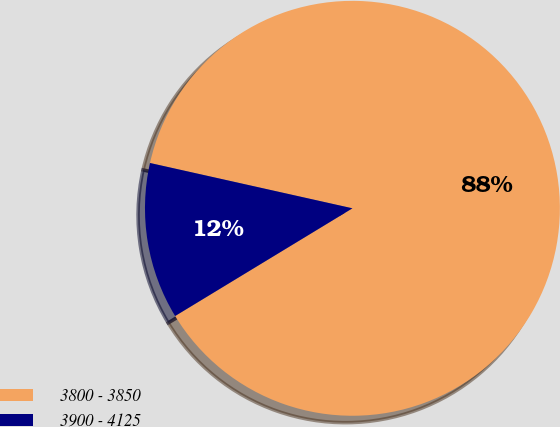Convert chart. <chart><loc_0><loc_0><loc_500><loc_500><pie_chart><fcel>3800 - 3850<fcel>3900 - 4125<nl><fcel>87.81%<fcel>12.19%<nl></chart> 